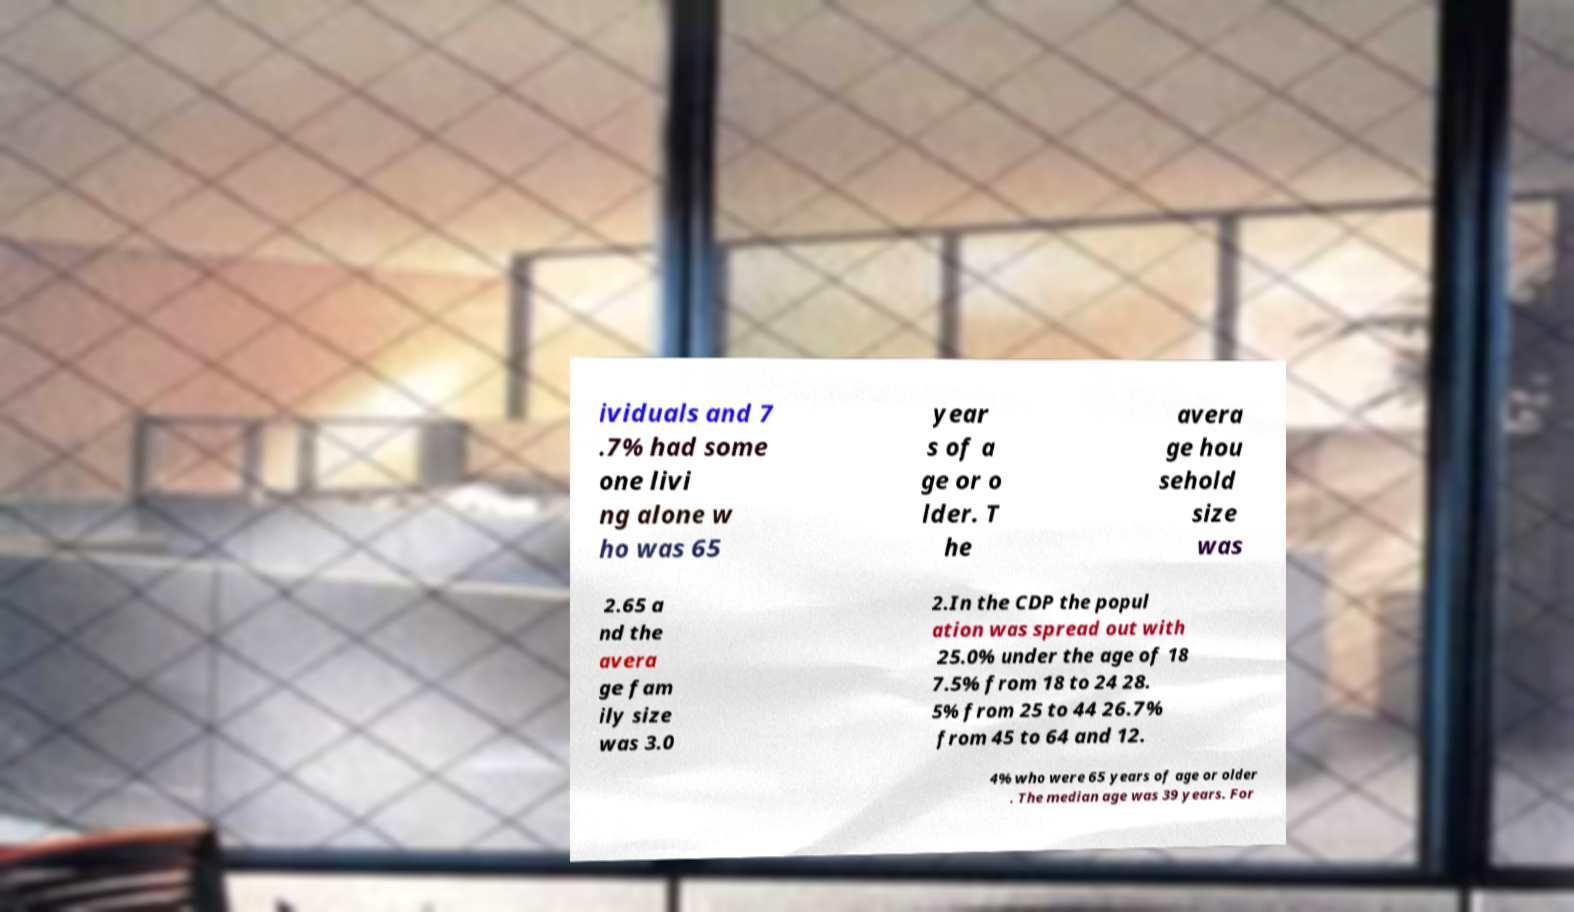What messages or text are displayed in this image? I need them in a readable, typed format. ividuals and 7 .7% had some one livi ng alone w ho was 65 year s of a ge or o lder. T he avera ge hou sehold size was 2.65 a nd the avera ge fam ily size was 3.0 2.In the CDP the popul ation was spread out with 25.0% under the age of 18 7.5% from 18 to 24 28. 5% from 25 to 44 26.7% from 45 to 64 and 12. 4% who were 65 years of age or older . The median age was 39 years. For 